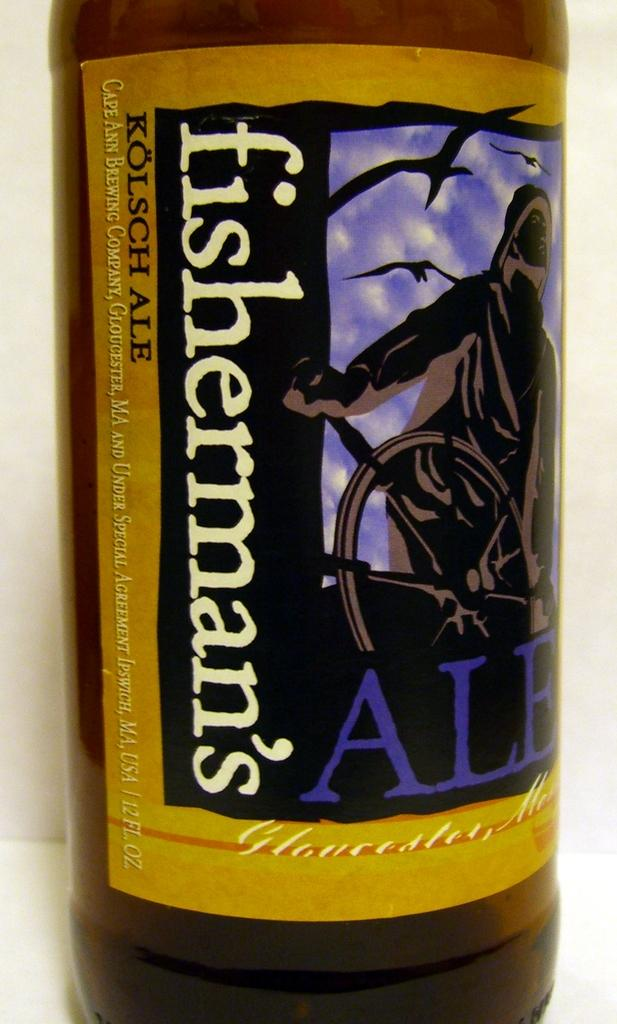Provide a one-sentence caption for the provided image. a close up of a bottle of Fisherman's ale. 